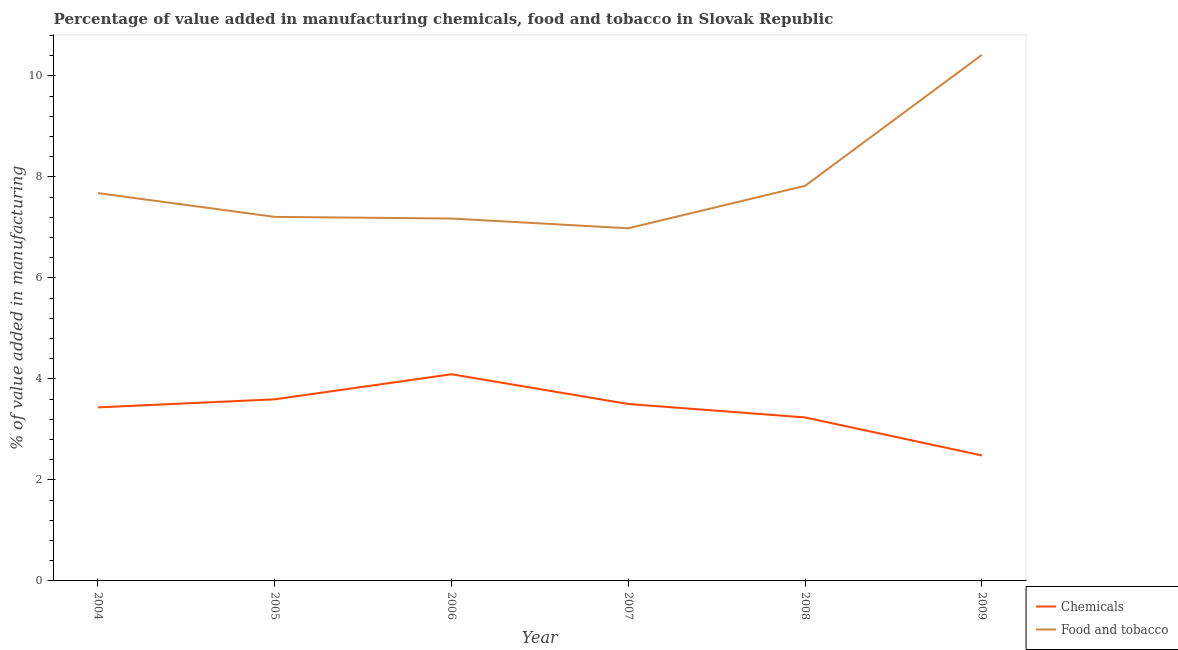How many different coloured lines are there?
Offer a very short reply. 2. What is the value added by  manufacturing chemicals in 2004?
Give a very brief answer. 3.44. Across all years, what is the maximum value added by manufacturing food and tobacco?
Give a very brief answer. 10.42. Across all years, what is the minimum value added by manufacturing food and tobacco?
Your response must be concise. 6.98. In which year was the value added by manufacturing food and tobacco maximum?
Provide a short and direct response. 2009. In which year was the value added by manufacturing food and tobacco minimum?
Give a very brief answer. 2007. What is the total value added by manufacturing food and tobacco in the graph?
Your response must be concise. 47.29. What is the difference between the value added by manufacturing food and tobacco in 2004 and that in 2008?
Offer a terse response. -0.14. What is the difference between the value added by manufacturing food and tobacco in 2009 and the value added by  manufacturing chemicals in 2006?
Make the answer very short. 6.32. What is the average value added by manufacturing food and tobacco per year?
Your response must be concise. 7.88. In the year 2008, what is the difference between the value added by  manufacturing chemicals and value added by manufacturing food and tobacco?
Keep it short and to the point. -4.59. What is the ratio of the value added by  manufacturing chemicals in 2005 to that in 2009?
Your answer should be compact. 1.45. Is the value added by  manufacturing chemicals in 2004 less than that in 2006?
Ensure brevity in your answer.  Yes. Is the difference between the value added by manufacturing food and tobacco in 2006 and 2008 greater than the difference between the value added by  manufacturing chemicals in 2006 and 2008?
Keep it short and to the point. No. What is the difference between the highest and the second highest value added by  manufacturing chemicals?
Ensure brevity in your answer.  0.5. What is the difference between the highest and the lowest value added by  manufacturing chemicals?
Offer a terse response. 1.61. In how many years, is the value added by manufacturing food and tobacco greater than the average value added by manufacturing food and tobacco taken over all years?
Keep it short and to the point. 1. Is the sum of the value added by manufacturing food and tobacco in 2004 and 2008 greater than the maximum value added by  manufacturing chemicals across all years?
Your answer should be very brief. Yes. Is the value added by  manufacturing chemicals strictly greater than the value added by manufacturing food and tobacco over the years?
Offer a terse response. No. How many lines are there?
Provide a succinct answer. 2. What is the difference between two consecutive major ticks on the Y-axis?
Your response must be concise. 2. Are the values on the major ticks of Y-axis written in scientific E-notation?
Provide a short and direct response. No. What is the title of the graph?
Provide a succinct answer. Percentage of value added in manufacturing chemicals, food and tobacco in Slovak Republic. Does "Goods and services" appear as one of the legend labels in the graph?
Offer a terse response. No. What is the label or title of the X-axis?
Ensure brevity in your answer.  Year. What is the label or title of the Y-axis?
Ensure brevity in your answer.  % of value added in manufacturing. What is the % of value added in manufacturing in Chemicals in 2004?
Your answer should be compact. 3.44. What is the % of value added in manufacturing in Food and tobacco in 2004?
Provide a short and direct response. 7.68. What is the % of value added in manufacturing in Chemicals in 2005?
Your answer should be compact. 3.6. What is the % of value added in manufacturing of Food and tobacco in 2005?
Give a very brief answer. 7.21. What is the % of value added in manufacturing in Chemicals in 2006?
Provide a succinct answer. 4.09. What is the % of value added in manufacturing of Food and tobacco in 2006?
Your response must be concise. 7.18. What is the % of value added in manufacturing of Chemicals in 2007?
Provide a succinct answer. 3.5. What is the % of value added in manufacturing in Food and tobacco in 2007?
Give a very brief answer. 6.98. What is the % of value added in manufacturing of Chemicals in 2008?
Make the answer very short. 3.24. What is the % of value added in manufacturing of Food and tobacco in 2008?
Offer a very short reply. 7.82. What is the % of value added in manufacturing in Chemicals in 2009?
Make the answer very short. 2.48. What is the % of value added in manufacturing of Food and tobacco in 2009?
Keep it short and to the point. 10.42. Across all years, what is the maximum % of value added in manufacturing in Chemicals?
Provide a succinct answer. 4.09. Across all years, what is the maximum % of value added in manufacturing of Food and tobacco?
Your response must be concise. 10.42. Across all years, what is the minimum % of value added in manufacturing of Chemicals?
Offer a very short reply. 2.48. Across all years, what is the minimum % of value added in manufacturing of Food and tobacco?
Provide a succinct answer. 6.98. What is the total % of value added in manufacturing of Chemicals in the graph?
Your answer should be very brief. 20.35. What is the total % of value added in manufacturing of Food and tobacco in the graph?
Keep it short and to the point. 47.29. What is the difference between the % of value added in manufacturing in Chemicals in 2004 and that in 2005?
Provide a succinct answer. -0.16. What is the difference between the % of value added in manufacturing of Food and tobacco in 2004 and that in 2005?
Your response must be concise. 0.47. What is the difference between the % of value added in manufacturing of Chemicals in 2004 and that in 2006?
Keep it short and to the point. -0.66. What is the difference between the % of value added in manufacturing of Food and tobacco in 2004 and that in 2006?
Provide a short and direct response. 0.5. What is the difference between the % of value added in manufacturing of Chemicals in 2004 and that in 2007?
Your answer should be compact. -0.07. What is the difference between the % of value added in manufacturing in Food and tobacco in 2004 and that in 2007?
Make the answer very short. 0.7. What is the difference between the % of value added in manufacturing in Chemicals in 2004 and that in 2008?
Keep it short and to the point. 0.2. What is the difference between the % of value added in manufacturing in Food and tobacco in 2004 and that in 2008?
Your answer should be very brief. -0.14. What is the difference between the % of value added in manufacturing of Chemicals in 2004 and that in 2009?
Your answer should be compact. 0.95. What is the difference between the % of value added in manufacturing in Food and tobacco in 2004 and that in 2009?
Your answer should be very brief. -2.74. What is the difference between the % of value added in manufacturing in Chemicals in 2005 and that in 2006?
Provide a short and direct response. -0.5. What is the difference between the % of value added in manufacturing of Food and tobacco in 2005 and that in 2006?
Your answer should be very brief. 0.03. What is the difference between the % of value added in manufacturing of Chemicals in 2005 and that in 2007?
Your answer should be compact. 0.09. What is the difference between the % of value added in manufacturing in Food and tobacco in 2005 and that in 2007?
Give a very brief answer. 0.23. What is the difference between the % of value added in manufacturing of Chemicals in 2005 and that in 2008?
Offer a very short reply. 0.36. What is the difference between the % of value added in manufacturing of Food and tobacco in 2005 and that in 2008?
Ensure brevity in your answer.  -0.61. What is the difference between the % of value added in manufacturing in Chemicals in 2005 and that in 2009?
Your response must be concise. 1.11. What is the difference between the % of value added in manufacturing of Food and tobacco in 2005 and that in 2009?
Make the answer very short. -3.21. What is the difference between the % of value added in manufacturing in Chemicals in 2006 and that in 2007?
Your response must be concise. 0.59. What is the difference between the % of value added in manufacturing in Food and tobacco in 2006 and that in 2007?
Keep it short and to the point. 0.19. What is the difference between the % of value added in manufacturing in Chemicals in 2006 and that in 2008?
Provide a succinct answer. 0.85. What is the difference between the % of value added in manufacturing of Food and tobacco in 2006 and that in 2008?
Provide a short and direct response. -0.65. What is the difference between the % of value added in manufacturing in Chemicals in 2006 and that in 2009?
Provide a succinct answer. 1.61. What is the difference between the % of value added in manufacturing of Food and tobacco in 2006 and that in 2009?
Your answer should be very brief. -3.24. What is the difference between the % of value added in manufacturing of Chemicals in 2007 and that in 2008?
Offer a terse response. 0.27. What is the difference between the % of value added in manufacturing in Food and tobacco in 2007 and that in 2008?
Your answer should be very brief. -0.84. What is the difference between the % of value added in manufacturing in Chemicals in 2007 and that in 2009?
Offer a terse response. 1.02. What is the difference between the % of value added in manufacturing in Food and tobacco in 2007 and that in 2009?
Keep it short and to the point. -3.43. What is the difference between the % of value added in manufacturing of Chemicals in 2008 and that in 2009?
Give a very brief answer. 0.75. What is the difference between the % of value added in manufacturing of Food and tobacco in 2008 and that in 2009?
Your response must be concise. -2.59. What is the difference between the % of value added in manufacturing of Chemicals in 2004 and the % of value added in manufacturing of Food and tobacco in 2005?
Offer a terse response. -3.77. What is the difference between the % of value added in manufacturing of Chemicals in 2004 and the % of value added in manufacturing of Food and tobacco in 2006?
Keep it short and to the point. -3.74. What is the difference between the % of value added in manufacturing in Chemicals in 2004 and the % of value added in manufacturing in Food and tobacco in 2007?
Keep it short and to the point. -3.55. What is the difference between the % of value added in manufacturing in Chemicals in 2004 and the % of value added in manufacturing in Food and tobacco in 2008?
Make the answer very short. -4.39. What is the difference between the % of value added in manufacturing of Chemicals in 2004 and the % of value added in manufacturing of Food and tobacco in 2009?
Ensure brevity in your answer.  -6.98. What is the difference between the % of value added in manufacturing in Chemicals in 2005 and the % of value added in manufacturing in Food and tobacco in 2006?
Your response must be concise. -3.58. What is the difference between the % of value added in manufacturing in Chemicals in 2005 and the % of value added in manufacturing in Food and tobacco in 2007?
Give a very brief answer. -3.39. What is the difference between the % of value added in manufacturing of Chemicals in 2005 and the % of value added in manufacturing of Food and tobacco in 2008?
Offer a terse response. -4.23. What is the difference between the % of value added in manufacturing of Chemicals in 2005 and the % of value added in manufacturing of Food and tobacco in 2009?
Ensure brevity in your answer.  -6.82. What is the difference between the % of value added in manufacturing of Chemicals in 2006 and the % of value added in manufacturing of Food and tobacco in 2007?
Provide a short and direct response. -2.89. What is the difference between the % of value added in manufacturing in Chemicals in 2006 and the % of value added in manufacturing in Food and tobacco in 2008?
Your response must be concise. -3.73. What is the difference between the % of value added in manufacturing in Chemicals in 2006 and the % of value added in manufacturing in Food and tobacco in 2009?
Provide a succinct answer. -6.32. What is the difference between the % of value added in manufacturing in Chemicals in 2007 and the % of value added in manufacturing in Food and tobacco in 2008?
Your answer should be very brief. -4.32. What is the difference between the % of value added in manufacturing in Chemicals in 2007 and the % of value added in manufacturing in Food and tobacco in 2009?
Your response must be concise. -6.91. What is the difference between the % of value added in manufacturing of Chemicals in 2008 and the % of value added in manufacturing of Food and tobacco in 2009?
Your answer should be compact. -7.18. What is the average % of value added in manufacturing in Chemicals per year?
Keep it short and to the point. 3.39. What is the average % of value added in manufacturing of Food and tobacco per year?
Give a very brief answer. 7.88. In the year 2004, what is the difference between the % of value added in manufacturing in Chemicals and % of value added in manufacturing in Food and tobacco?
Your response must be concise. -4.24. In the year 2005, what is the difference between the % of value added in manufacturing in Chemicals and % of value added in manufacturing in Food and tobacco?
Give a very brief answer. -3.61. In the year 2006, what is the difference between the % of value added in manufacturing in Chemicals and % of value added in manufacturing in Food and tobacco?
Give a very brief answer. -3.08. In the year 2007, what is the difference between the % of value added in manufacturing in Chemicals and % of value added in manufacturing in Food and tobacco?
Give a very brief answer. -3.48. In the year 2008, what is the difference between the % of value added in manufacturing in Chemicals and % of value added in manufacturing in Food and tobacco?
Make the answer very short. -4.59. In the year 2009, what is the difference between the % of value added in manufacturing of Chemicals and % of value added in manufacturing of Food and tobacco?
Provide a short and direct response. -7.93. What is the ratio of the % of value added in manufacturing in Chemicals in 2004 to that in 2005?
Your answer should be very brief. 0.96. What is the ratio of the % of value added in manufacturing in Food and tobacco in 2004 to that in 2005?
Keep it short and to the point. 1.07. What is the ratio of the % of value added in manufacturing of Chemicals in 2004 to that in 2006?
Offer a very short reply. 0.84. What is the ratio of the % of value added in manufacturing in Food and tobacco in 2004 to that in 2006?
Keep it short and to the point. 1.07. What is the ratio of the % of value added in manufacturing of Chemicals in 2004 to that in 2007?
Your answer should be very brief. 0.98. What is the ratio of the % of value added in manufacturing in Food and tobacco in 2004 to that in 2007?
Offer a very short reply. 1.1. What is the ratio of the % of value added in manufacturing of Chemicals in 2004 to that in 2008?
Your answer should be very brief. 1.06. What is the ratio of the % of value added in manufacturing in Food and tobacco in 2004 to that in 2008?
Make the answer very short. 0.98. What is the ratio of the % of value added in manufacturing of Chemicals in 2004 to that in 2009?
Offer a very short reply. 1.38. What is the ratio of the % of value added in manufacturing in Food and tobacco in 2004 to that in 2009?
Provide a short and direct response. 0.74. What is the ratio of the % of value added in manufacturing in Chemicals in 2005 to that in 2006?
Make the answer very short. 0.88. What is the ratio of the % of value added in manufacturing in Food and tobacco in 2005 to that in 2006?
Provide a succinct answer. 1. What is the ratio of the % of value added in manufacturing in Chemicals in 2005 to that in 2007?
Offer a terse response. 1.03. What is the ratio of the % of value added in manufacturing in Food and tobacco in 2005 to that in 2007?
Provide a short and direct response. 1.03. What is the ratio of the % of value added in manufacturing of Chemicals in 2005 to that in 2008?
Keep it short and to the point. 1.11. What is the ratio of the % of value added in manufacturing of Food and tobacco in 2005 to that in 2008?
Provide a short and direct response. 0.92. What is the ratio of the % of value added in manufacturing in Chemicals in 2005 to that in 2009?
Offer a very short reply. 1.45. What is the ratio of the % of value added in manufacturing in Food and tobacco in 2005 to that in 2009?
Make the answer very short. 0.69. What is the ratio of the % of value added in manufacturing of Chemicals in 2006 to that in 2007?
Make the answer very short. 1.17. What is the ratio of the % of value added in manufacturing of Food and tobacco in 2006 to that in 2007?
Make the answer very short. 1.03. What is the ratio of the % of value added in manufacturing in Chemicals in 2006 to that in 2008?
Provide a short and direct response. 1.26. What is the ratio of the % of value added in manufacturing of Food and tobacco in 2006 to that in 2008?
Offer a very short reply. 0.92. What is the ratio of the % of value added in manufacturing of Chemicals in 2006 to that in 2009?
Give a very brief answer. 1.65. What is the ratio of the % of value added in manufacturing in Food and tobacco in 2006 to that in 2009?
Your answer should be very brief. 0.69. What is the ratio of the % of value added in manufacturing of Chemicals in 2007 to that in 2008?
Your answer should be very brief. 1.08. What is the ratio of the % of value added in manufacturing of Food and tobacco in 2007 to that in 2008?
Provide a succinct answer. 0.89. What is the ratio of the % of value added in manufacturing in Chemicals in 2007 to that in 2009?
Provide a succinct answer. 1.41. What is the ratio of the % of value added in manufacturing in Food and tobacco in 2007 to that in 2009?
Your answer should be very brief. 0.67. What is the ratio of the % of value added in manufacturing in Chemicals in 2008 to that in 2009?
Your answer should be compact. 1.3. What is the ratio of the % of value added in manufacturing of Food and tobacco in 2008 to that in 2009?
Your answer should be compact. 0.75. What is the difference between the highest and the second highest % of value added in manufacturing of Chemicals?
Offer a terse response. 0.5. What is the difference between the highest and the second highest % of value added in manufacturing in Food and tobacco?
Give a very brief answer. 2.59. What is the difference between the highest and the lowest % of value added in manufacturing of Chemicals?
Your answer should be very brief. 1.61. What is the difference between the highest and the lowest % of value added in manufacturing of Food and tobacco?
Keep it short and to the point. 3.43. 